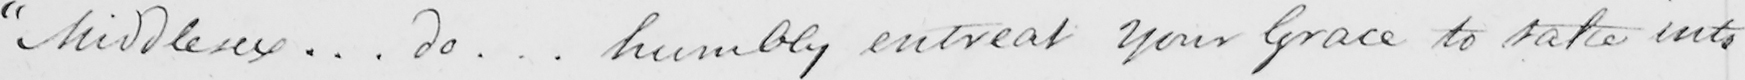Transcribe the text shown in this historical manuscript line. " Middlesex .. . do .. . humbly entreat Your Grace to take into 